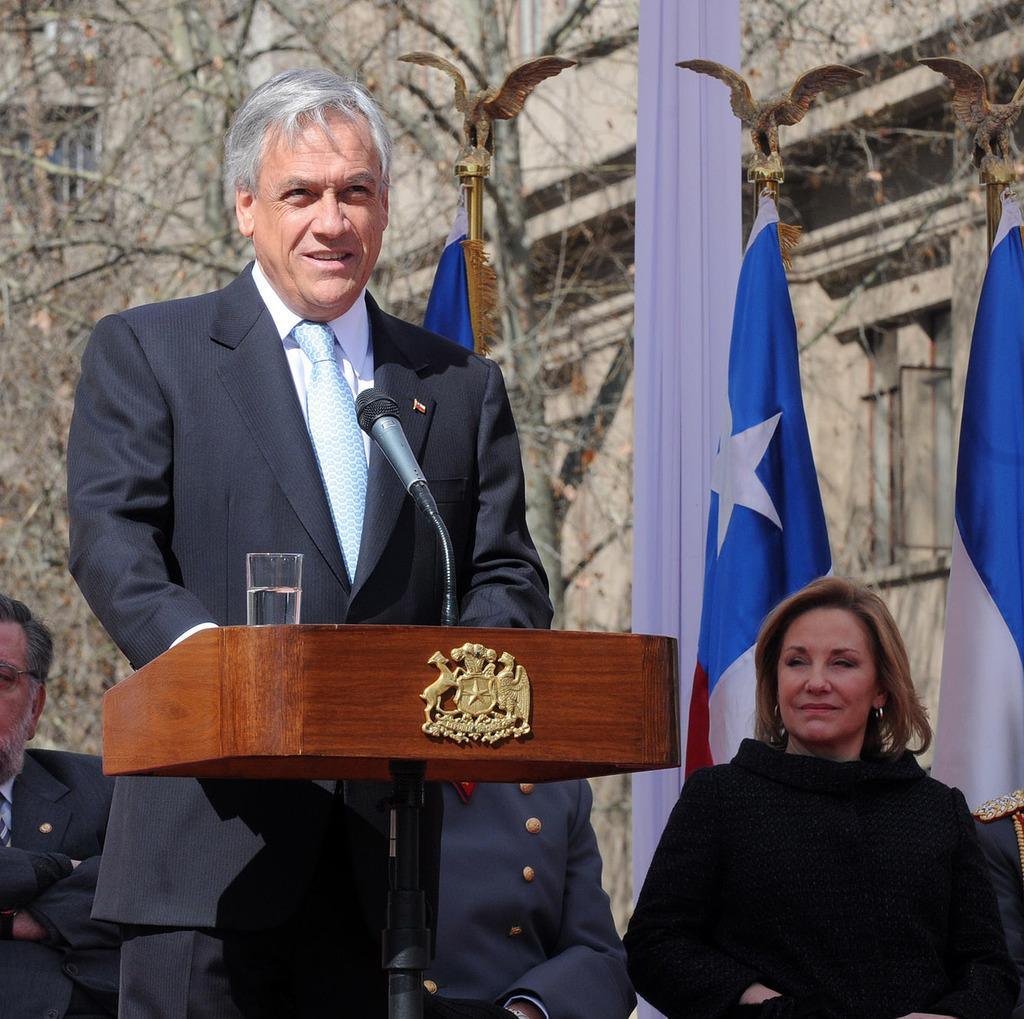How many people are in the image? There are people in the image, but the exact number is not specified. What is the person in front of the podium doing? The person is standing in front of a podium. What is on the podium? There is a microphone and a glass on the podium. What can be seen in the background of the image? There are flags and a building in the image. What year is the record being played in the image? There is no record or music player present in the image, so it is not possible to determine the year or any music-related information. 